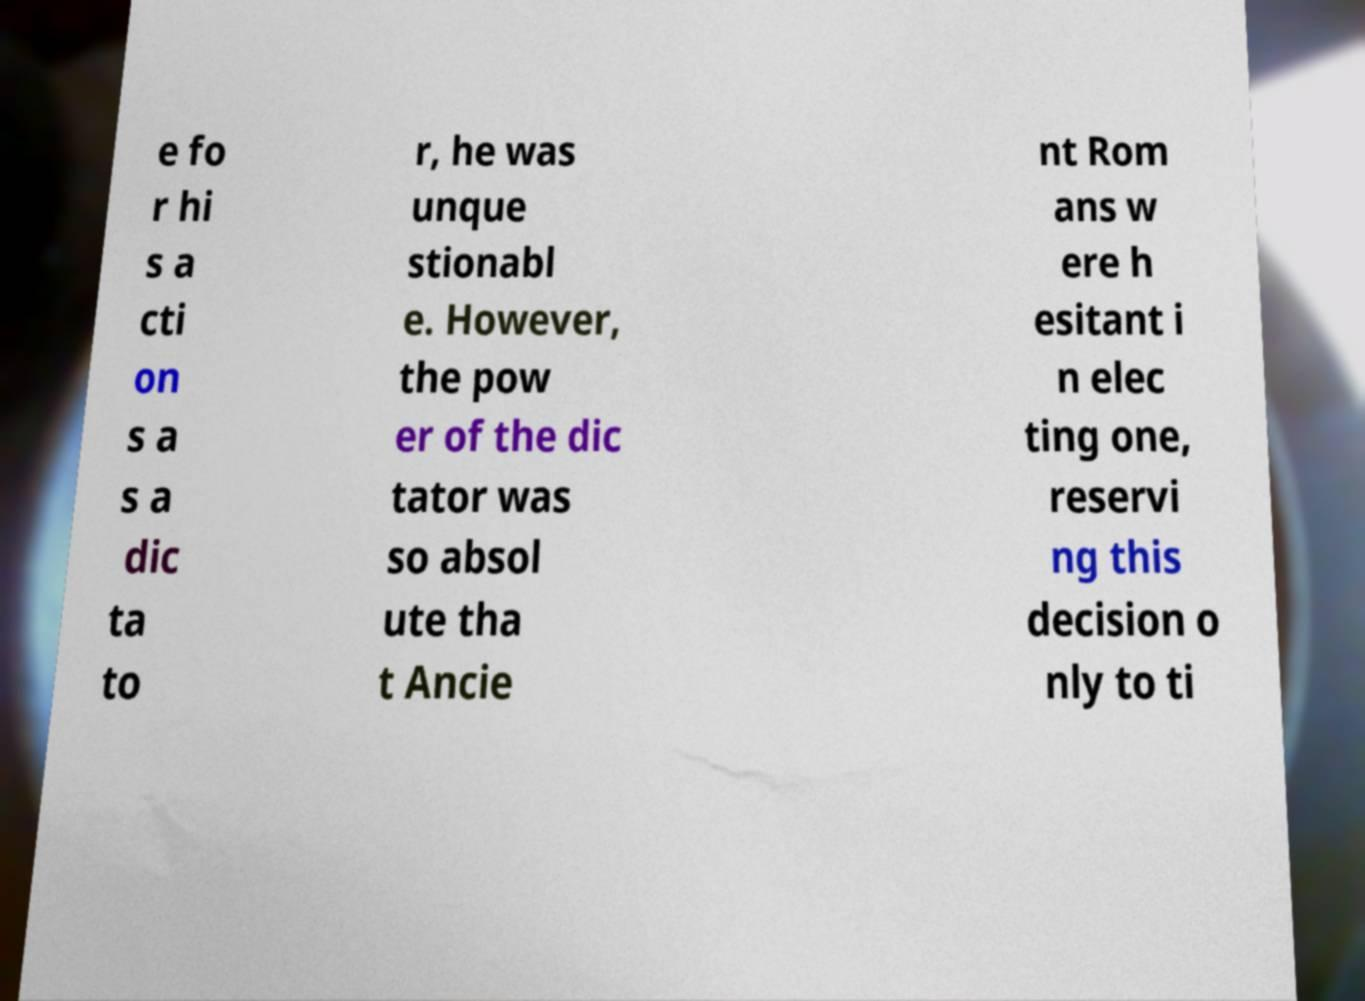Could you extract and type out the text from this image? e fo r hi s a cti on s a s a dic ta to r, he was unque stionabl e. However, the pow er of the dic tator was so absol ute tha t Ancie nt Rom ans w ere h esitant i n elec ting one, reservi ng this decision o nly to ti 